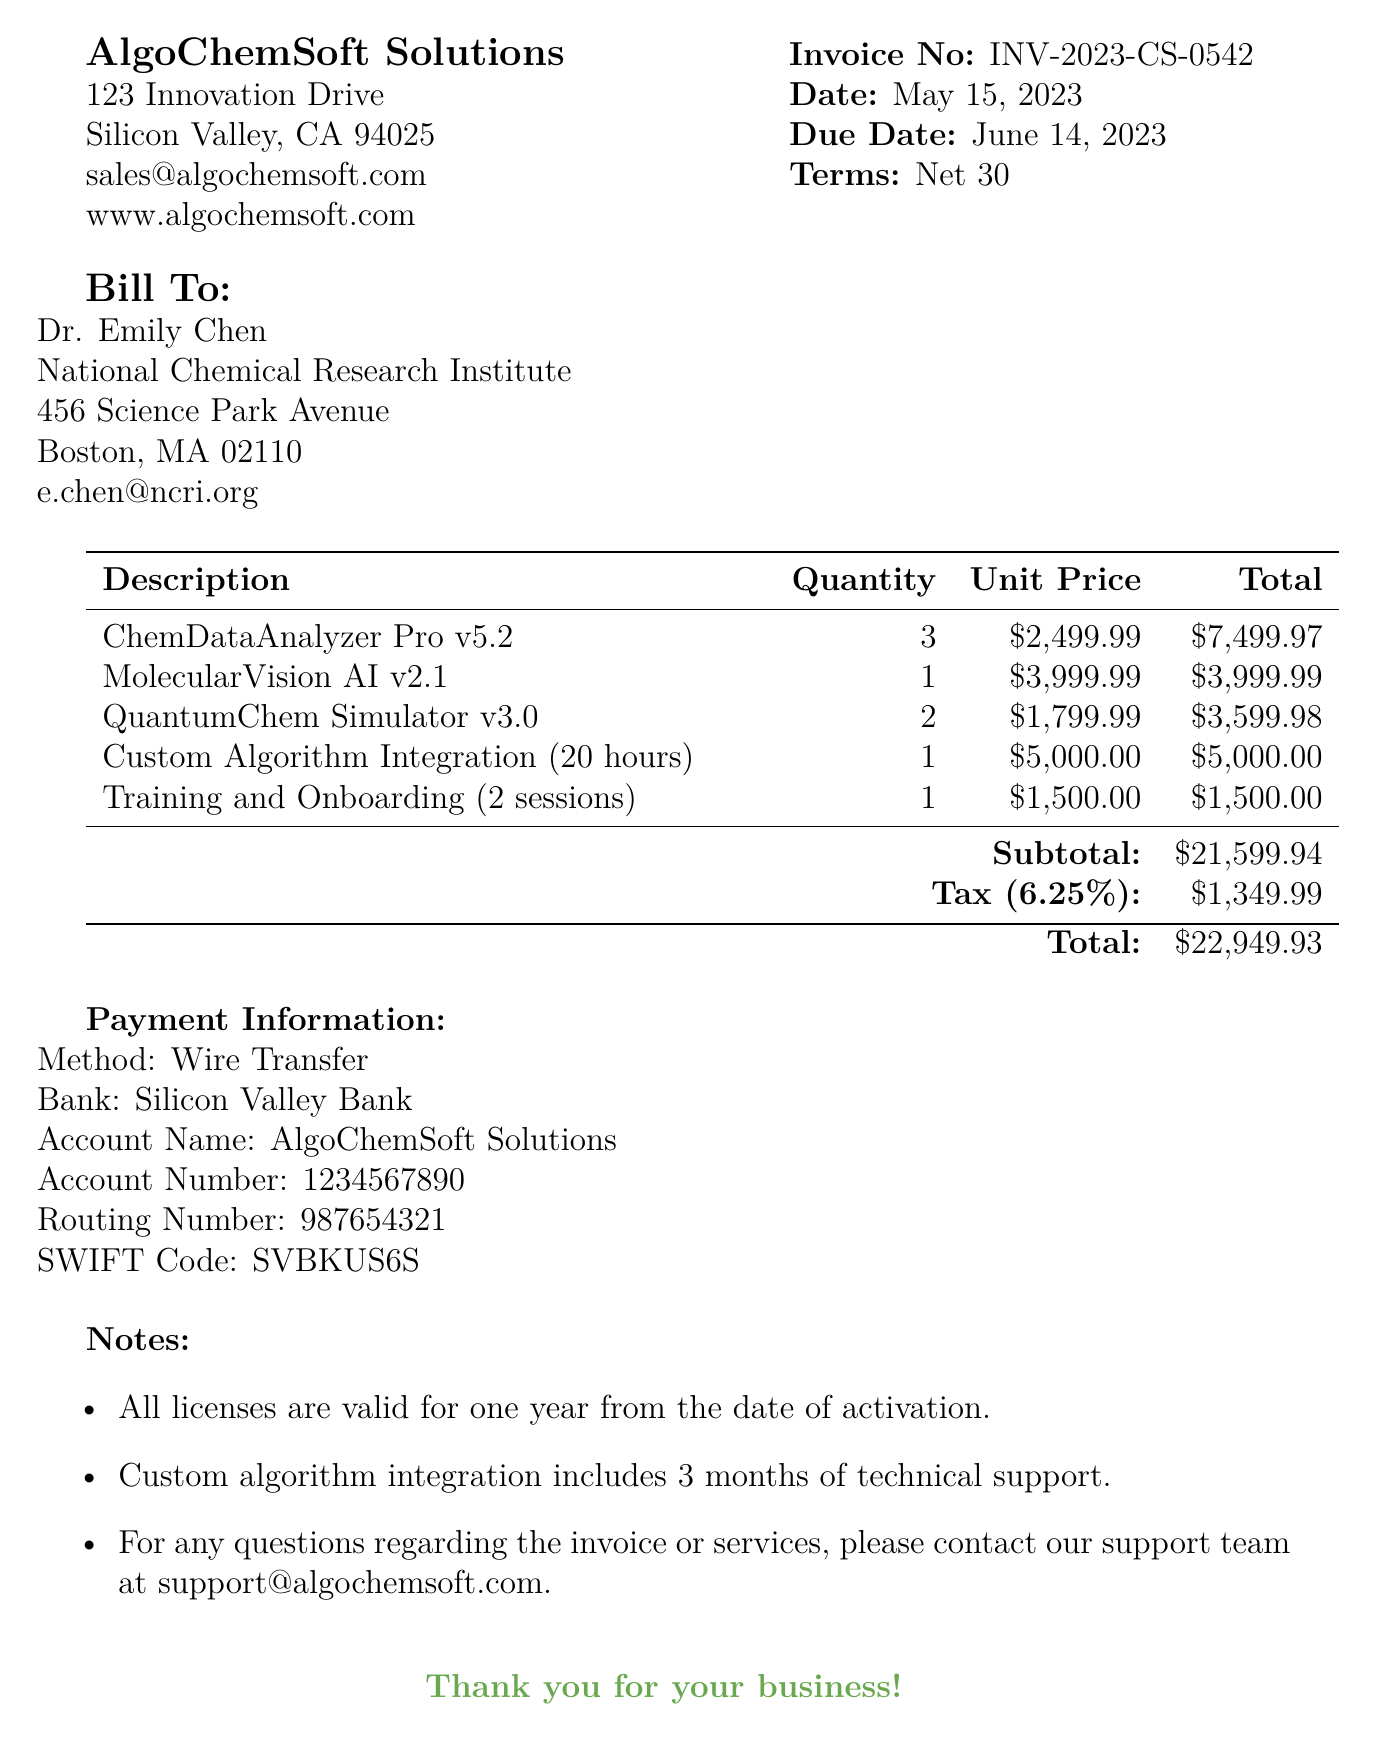what is the invoice number? The invoice number is explicitly stated in the document as INV-2023-CS-0542.
Answer: INV-2023-CS-0542 who is the vendor? The vendor's name is provided in the document under vendor info, which is AlgoChemSoft Solutions.
Answer: AlgoChemSoft Solutions what is the total amount due? The total amount due is calculated as the sum of the subtotal and tax, which equals $22,949.93.
Answer: $22,949.93 how many licenses for ChemDataAnalyzer Pro were purchased? The quantity of ChemDataAnalyzer Pro licenses is mentioned in the software licenses section, which is 3.
Answer: 3 what type of payment method is specified? The payment method is indicated in the payment information section, which states Wire Transfer.
Answer: Wire Transfer what is the tax rate applied to this invoice? The tax rate for the invoice is listed in the totals section as 6.25%.
Answer: 6.25% what additional service includes technical support? The document states that Custom Algorithm Integration includes 3 months of technical support.
Answer: Custom Algorithm Integration when is the payment due? The due date for the payment is provided as June 14, 2023, under invoice details.
Answer: June 14, 2023 how many training sessions are included? The number of training sessions included is mentioned as 2 in the additional services section.
Answer: 2 